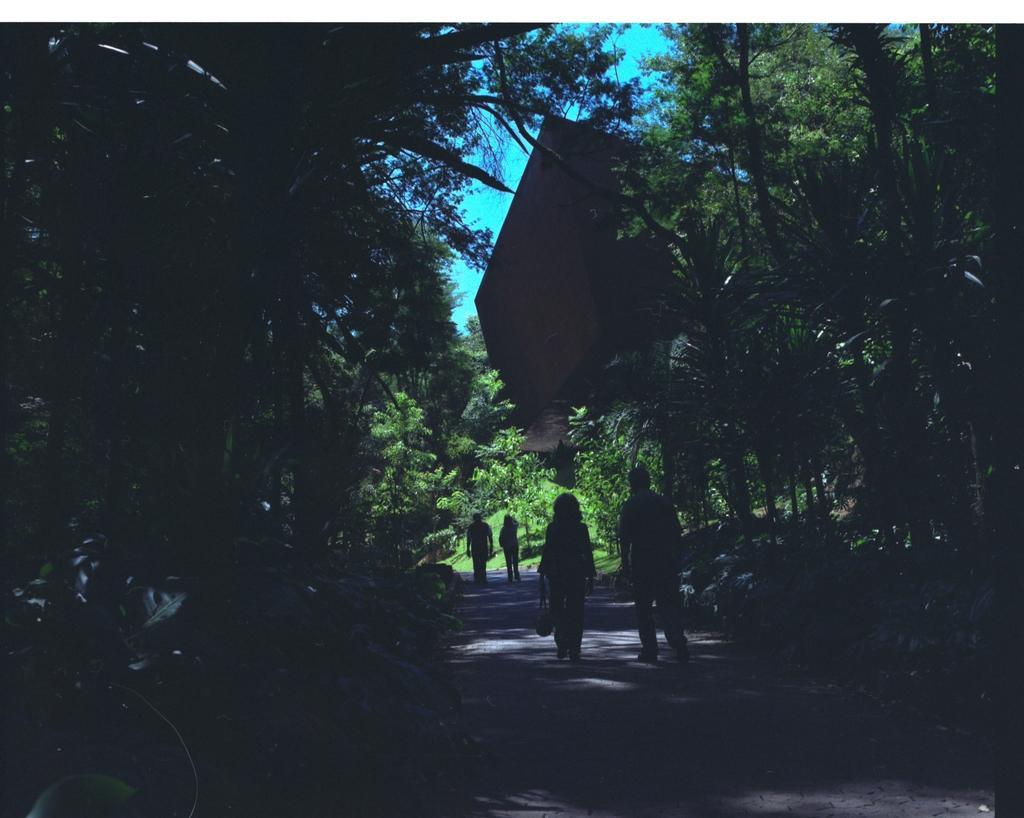How would you summarize this image in a sentence or two? In this image there are four people walking on the road, and in the background there are plants, trees, a building, sky. 